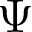<formula> <loc_0><loc_0><loc_500><loc_500>\Psi</formula> 